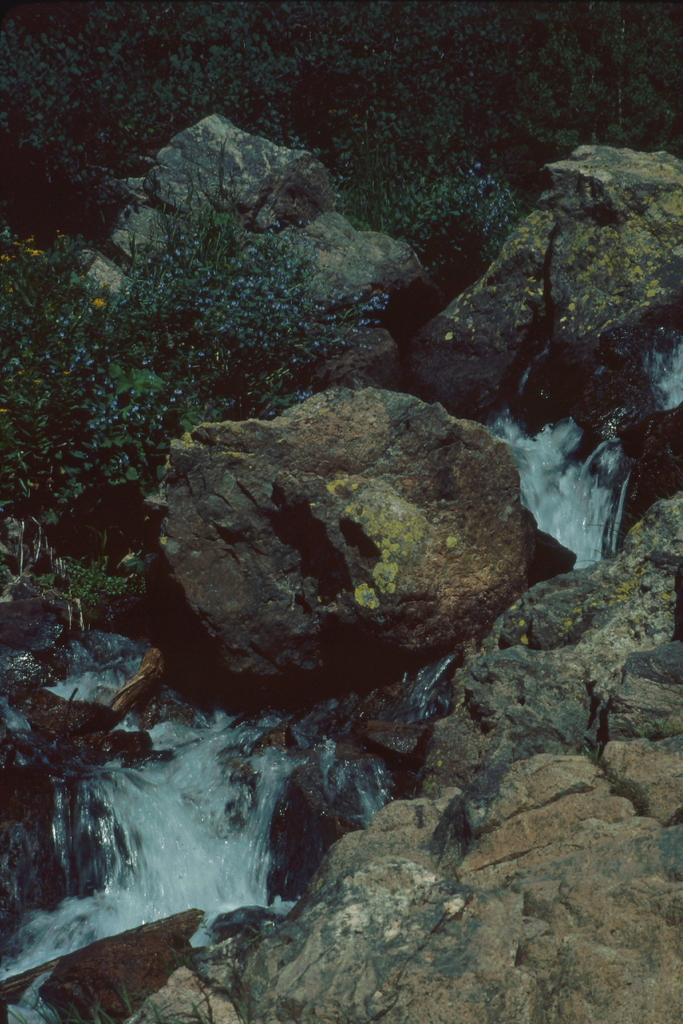What is the primary element in the picture? There is water in the picture. What other objects or features can be seen in the picture? There are rocks and plants in the picture. What type of wire is used to hold the wax in the picture? There is no wire or wax present in the picture; it features water, rocks, and plants. 